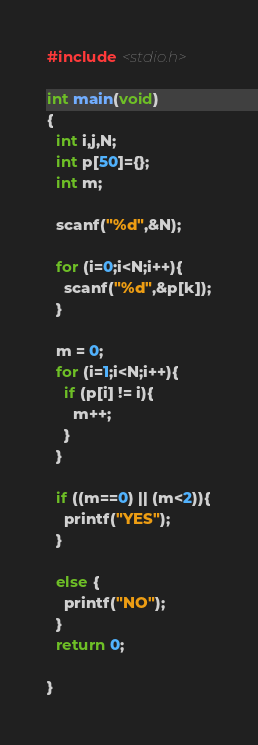Convert code to text. <code><loc_0><loc_0><loc_500><loc_500><_C_>#include <stdio.h>

int main(void)
{
  int i,j,N;
  int p[50]={};
  int m;

  scanf("%d",&N);

  for (i=0;i<N;i++){
    scanf("%d",&p[k]);
  }

  m = 0;
  for (i=1;i<N;i++){
    if (p[i] != i){
      m++;
    }
  }
  
  if ((m==0) || (m<2)){
    printf("YES");
  }

  else {
    printf("NO");
  }
  return 0; 
  
}
</code> 